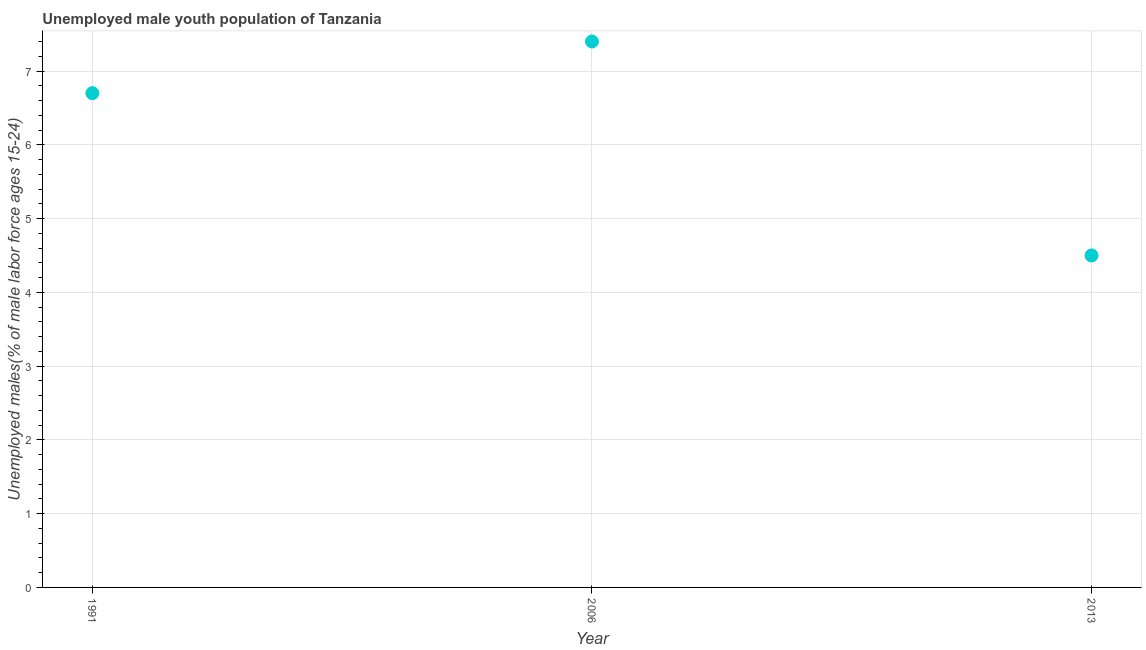What is the unemployed male youth in 2006?
Offer a terse response. 7.4. Across all years, what is the maximum unemployed male youth?
Keep it short and to the point. 7.4. Across all years, what is the minimum unemployed male youth?
Make the answer very short. 4.5. What is the sum of the unemployed male youth?
Your answer should be compact. 18.6. What is the difference between the unemployed male youth in 2006 and 2013?
Your answer should be very brief. 2.9. What is the average unemployed male youth per year?
Your response must be concise. 6.2. What is the median unemployed male youth?
Keep it short and to the point. 6.7. What is the ratio of the unemployed male youth in 1991 to that in 2013?
Give a very brief answer. 1.49. Is the difference between the unemployed male youth in 2006 and 2013 greater than the difference between any two years?
Your answer should be very brief. Yes. What is the difference between the highest and the second highest unemployed male youth?
Offer a very short reply. 0.7. Is the sum of the unemployed male youth in 1991 and 2013 greater than the maximum unemployed male youth across all years?
Your answer should be compact. Yes. What is the difference between the highest and the lowest unemployed male youth?
Your answer should be very brief. 2.9. In how many years, is the unemployed male youth greater than the average unemployed male youth taken over all years?
Provide a short and direct response. 2. Are the values on the major ticks of Y-axis written in scientific E-notation?
Give a very brief answer. No. Does the graph contain any zero values?
Provide a succinct answer. No. Does the graph contain grids?
Keep it short and to the point. Yes. What is the title of the graph?
Your response must be concise. Unemployed male youth population of Tanzania. What is the label or title of the X-axis?
Offer a very short reply. Year. What is the label or title of the Y-axis?
Offer a terse response. Unemployed males(% of male labor force ages 15-24). What is the Unemployed males(% of male labor force ages 15-24) in 1991?
Offer a terse response. 6.7. What is the Unemployed males(% of male labor force ages 15-24) in 2006?
Provide a short and direct response. 7.4. What is the difference between the Unemployed males(% of male labor force ages 15-24) in 1991 and 2013?
Ensure brevity in your answer.  2.2. What is the ratio of the Unemployed males(% of male labor force ages 15-24) in 1991 to that in 2006?
Ensure brevity in your answer.  0.91. What is the ratio of the Unemployed males(% of male labor force ages 15-24) in 1991 to that in 2013?
Keep it short and to the point. 1.49. What is the ratio of the Unemployed males(% of male labor force ages 15-24) in 2006 to that in 2013?
Your answer should be very brief. 1.64. 